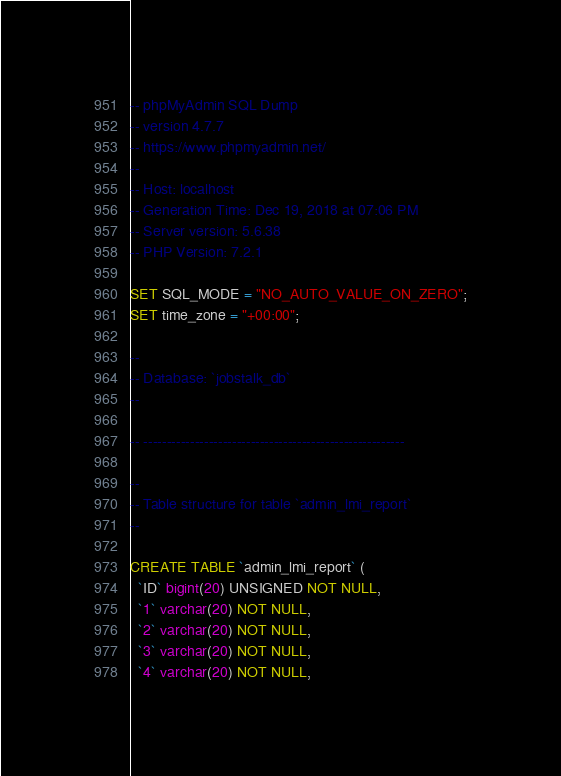Convert code to text. <code><loc_0><loc_0><loc_500><loc_500><_SQL_>-- phpMyAdmin SQL Dump
-- version 4.7.7
-- https://www.phpmyadmin.net/
--
-- Host: localhost
-- Generation Time: Dec 19, 2018 at 07:06 PM
-- Server version: 5.6.38
-- PHP Version: 7.2.1

SET SQL_MODE = "NO_AUTO_VALUE_ON_ZERO";
SET time_zone = "+00:00";

--
-- Database: `jobstalk_db`
--

-- --------------------------------------------------------

--
-- Table structure for table `admin_lmi_report`
--

CREATE TABLE `admin_lmi_report` (
  `ID` bigint(20) UNSIGNED NOT NULL,
  `1` varchar(20) NOT NULL,
  `2` varchar(20) NOT NULL,
  `3` varchar(20) NOT NULL,
  `4` varchar(20) NOT NULL,</code> 